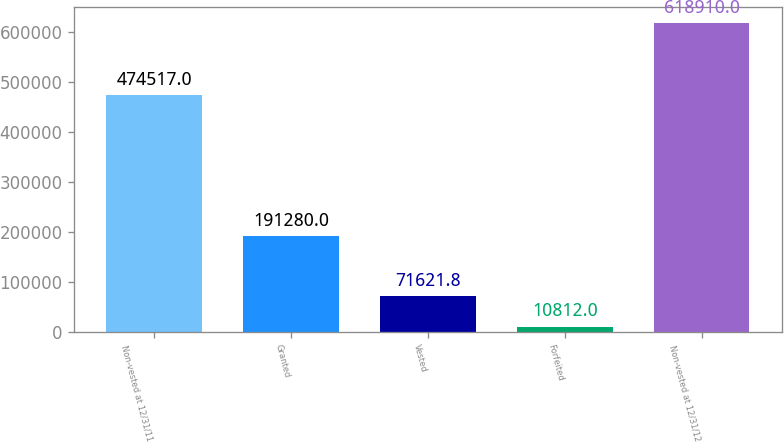Convert chart to OTSL. <chart><loc_0><loc_0><loc_500><loc_500><bar_chart><fcel>Non-vested at 12/31/11<fcel>Granted<fcel>Vested<fcel>Forfeited<fcel>Non-vested at 12/31/12<nl><fcel>474517<fcel>191280<fcel>71621.8<fcel>10812<fcel>618910<nl></chart> 